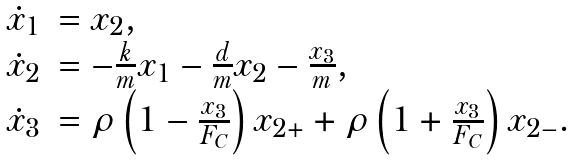Convert formula to latex. <formula><loc_0><loc_0><loc_500><loc_500>\begin{array} { r l } \dot { x } _ { 1 } & = x _ { 2 } , \\ \dot { x } _ { 2 } & = - \frac { k } { m } x _ { 1 } - \frac { d } { m } x _ { 2 } - \frac { x _ { 3 } } { m } , \\ \dot { x } _ { 3 } & = \rho \left ( 1 - \frac { x _ { 3 } } { F _ { C } } \right ) x _ { 2 + } + \rho \left ( 1 + \frac { x _ { 3 } } { F _ { C } } \right ) x _ { 2 - } . \end{array}</formula> 